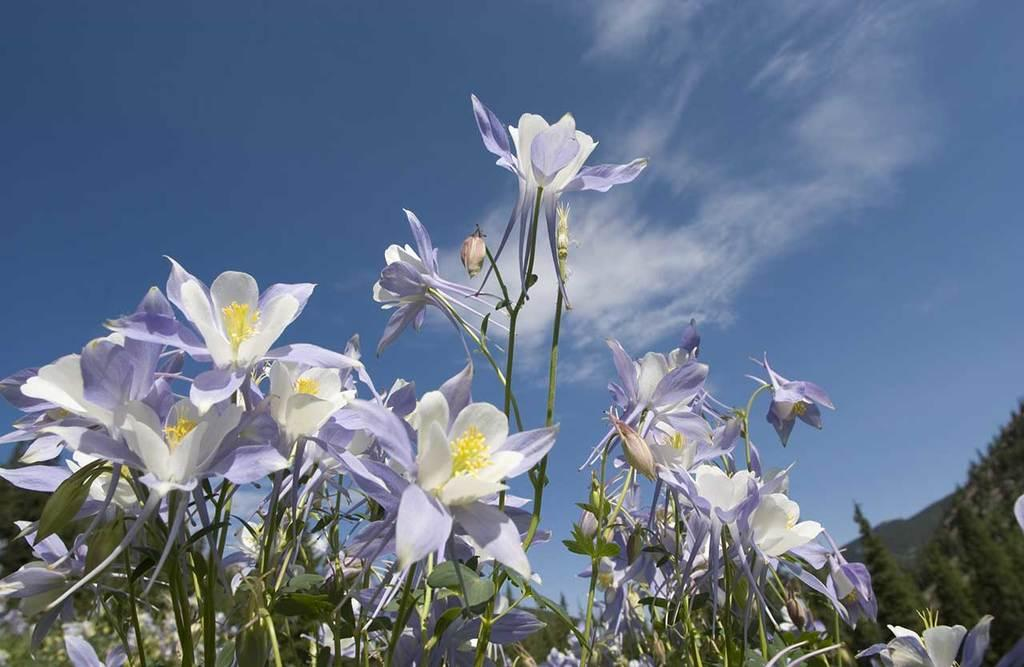What type of vegetation can be seen in the image? There are flowers and plants in the image. What is visible in the background of the image? There are trees and the sky visible in the background of the image. What type of apparel is the territory wearing in the image? There is no territory or apparel present in the image; it features flowers, plants, trees, and the sky. 